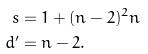<formula> <loc_0><loc_0><loc_500><loc_500>s & = 1 + ( n - 2 ) ^ { 2 } n \\ d ^ { \prime } & = n - 2 .</formula> 